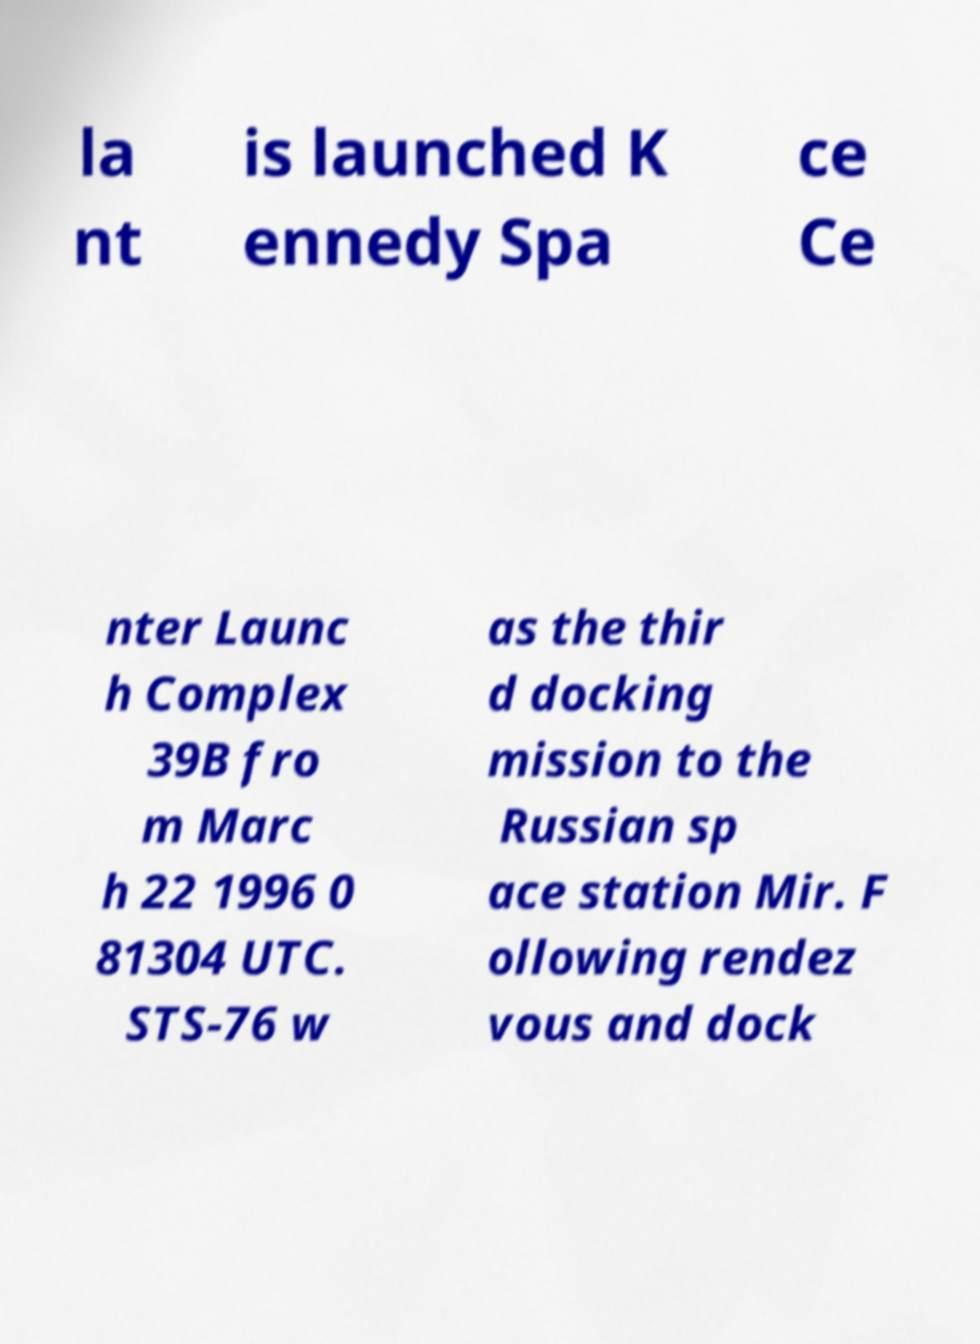What messages or text are displayed in this image? I need them in a readable, typed format. la nt is launched K ennedy Spa ce Ce nter Launc h Complex 39B fro m Marc h 22 1996 0 81304 UTC. STS-76 w as the thir d docking mission to the Russian sp ace station Mir. F ollowing rendez vous and dock 